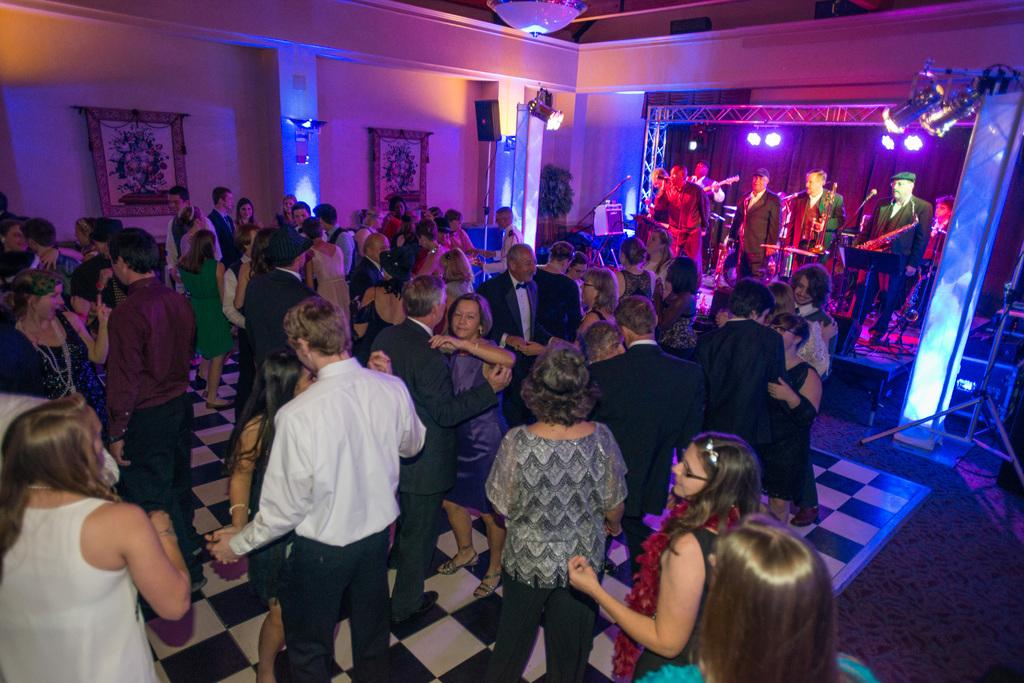What are the people in the image doing? There is a group of people dancing in the image. What else can be seen in the background of the image? There are people playing musical instruments in the background of the image. What can be observed in terms of lighting in the image? There are lights visible in the image. How many people have been bitten by a plough in the image? There is no plough or any indication of biting in the image. 